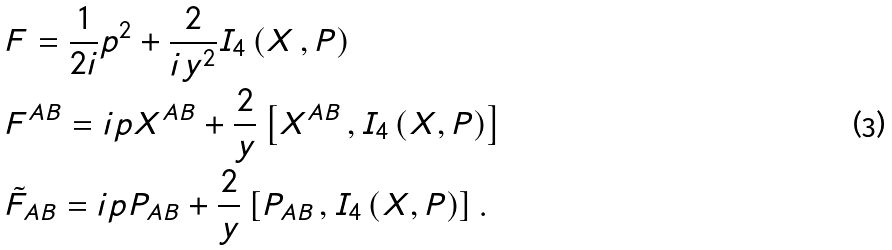Convert formula to latex. <formula><loc_0><loc_0><loc_500><loc_500>& F = \frac { 1 } { 2 i } p ^ { 2 } + \frac { 2 } { i y ^ { 2 } } I _ { 4 } \left ( X \, , P \right ) \\ & F ^ { A B } = i p X ^ { A B } + \frac { 2 } { y } \left [ X ^ { A B } \, , I _ { 4 } \left ( X , P \right ) \right ] \\ & \tilde { F } _ { A B } = i p P _ { A B } + \frac { 2 } { y } \left [ P _ { A B } \, , I _ { 4 } \left ( X , P \right ) \right ] .</formula> 